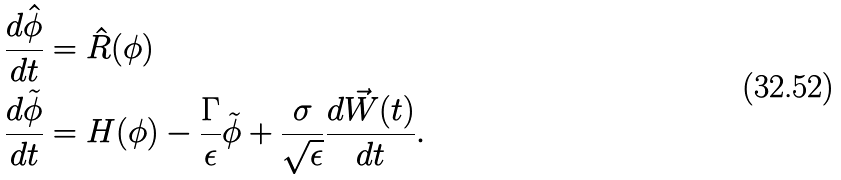Convert formula to latex. <formula><loc_0><loc_0><loc_500><loc_500>\frac { d \hat { \phi } } { d t } & = \hat { R } ( \phi ) \\ \frac { d \tilde { \phi } } { d t } & = H ( \phi ) - \frac { \Gamma } { \epsilon } \tilde { \phi } + \frac { \sigma } { \sqrt { \epsilon } } \frac { d \vec { W } ( t ) } { d t } .</formula> 